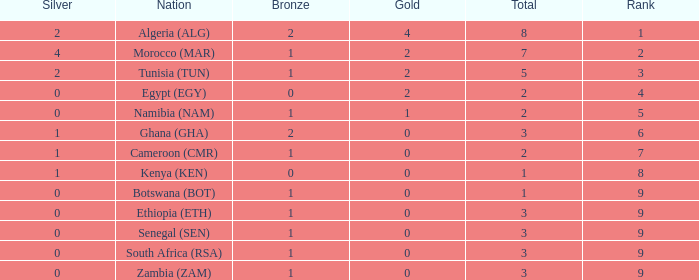What is the lowest Bronze with a Nation of egypt (egy) and with a Gold that is smaller than 2? None. Could you parse the entire table as a dict? {'header': ['Silver', 'Nation', 'Bronze', 'Gold', 'Total', 'Rank'], 'rows': [['2', 'Algeria (ALG)', '2', '4', '8', '1'], ['4', 'Morocco (MAR)', '1', '2', '7', '2'], ['2', 'Tunisia (TUN)', '1', '2', '5', '3'], ['0', 'Egypt (EGY)', '0', '2', '2', '4'], ['0', 'Namibia (NAM)', '1', '1', '2', '5'], ['1', 'Ghana (GHA)', '2', '0', '3', '6'], ['1', 'Cameroon (CMR)', '1', '0', '2', '7'], ['1', 'Kenya (KEN)', '0', '0', '1', '8'], ['0', 'Botswana (BOT)', '1', '0', '1', '9'], ['0', 'Ethiopia (ETH)', '1', '0', '3', '9'], ['0', 'Senegal (SEN)', '1', '0', '3', '9'], ['0', 'South Africa (RSA)', '1', '0', '3', '9'], ['0', 'Zambia (ZAM)', '1', '0', '3', '9']]} 